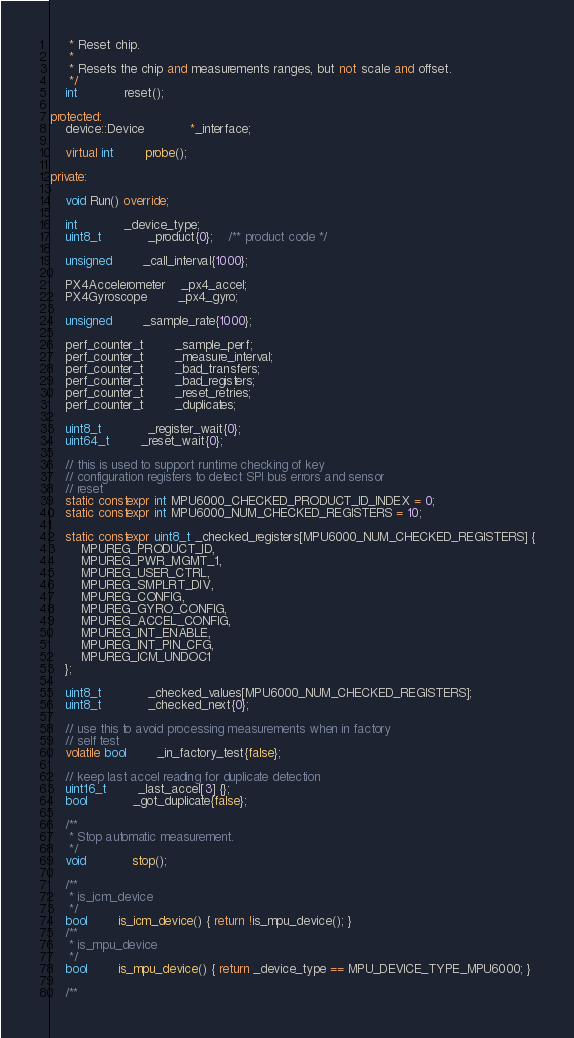<code> <loc_0><loc_0><loc_500><loc_500><_C++_>	 * Reset chip.
	 *
	 * Resets the chip and measurements ranges, but not scale and offset.
	 */
	int			reset();

protected:
	device::Device			*_interface;

	virtual int		probe();

private:

	void Run() override;

	int 			_device_type;
	uint8_t			_product{0};	/** product code */

	unsigned		_call_interval{1000};

	PX4Accelerometer	_px4_accel;
	PX4Gyroscope		_px4_gyro;

	unsigned		_sample_rate{1000};

	perf_counter_t		_sample_perf;
	perf_counter_t		_measure_interval;
	perf_counter_t		_bad_transfers;
	perf_counter_t		_bad_registers;
	perf_counter_t		_reset_retries;
	perf_counter_t		_duplicates;

	uint8_t			_register_wait{0};
	uint64_t		_reset_wait{0};

	// this is used to support runtime checking of key
	// configuration registers to detect SPI bus errors and sensor
	// reset
	static constexpr int MPU6000_CHECKED_PRODUCT_ID_INDEX = 0;
	static constexpr int MPU6000_NUM_CHECKED_REGISTERS = 10;

	static constexpr uint8_t _checked_registers[MPU6000_NUM_CHECKED_REGISTERS] {
		MPUREG_PRODUCT_ID,
		MPUREG_PWR_MGMT_1,
		MPUREG_USER_CTRL,
		MPUREG_SMPLRT_DIV,
		MPUREG_CONFIG,
		MPUREG_GYRO_CONFIG,
		MPUREG_ACCEL_CONFIG,
		MPUREG_INT_ENABLE,
		MPUREG_INT_PIN_CFG,
		MPUREG_ICM_UNDOC1
	};

	uint8_t			_checked_values[MPU6000_NUM_CHECKED_REGISTERS];
	uint8_t			_checked_next{0};

	// use this to avoid processing measurements when in factory
	// self test
	volatile bool		_in_factory_test{false};

	// keep last accel reading for duplicate detection
	uint16_t		_last_accel[3] {};
	bool			_got_duplicate{false};

	/**
	 * Stop automatic measurement.
	 */
	void			stop();

	/**
	 * is_icm_device
	 */
	bool 		is_icm_device() { return !is_mpu_device(); }
	/**
	 * is_mpu_device
	 */
	bool 		is_mpu_device() { return _device_type == MPU_DEVICE_TYPE_MPU6000; }

	/**</code> 